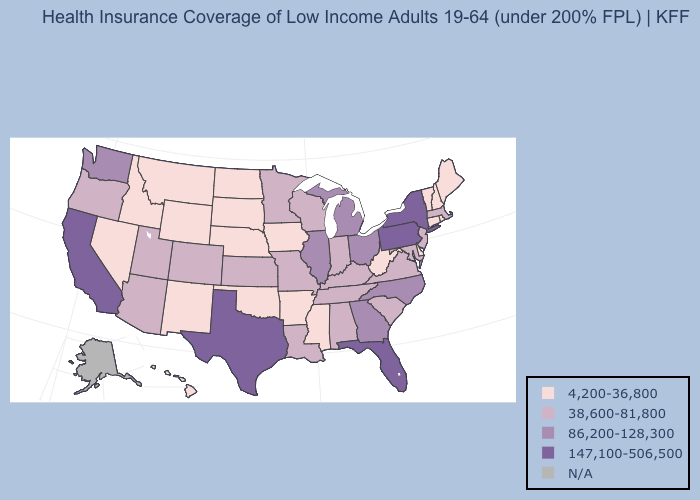Does Michigan have the highest value in the USA?
Answer briefly. No. Which states have the lowest value in the USA?
Be succinct. Arkansas, Connecticut, Delaware, Hawaii, Idaho, Iowa, Maine, Mississippi, Montana, Nebraska, Nevada, New Hampshire, New Mexico, North Dakota, Oklahoma, Rhode Island, South Dakota, Vermont, West Virginia, Wyoming. Name the states that have a value in the range 38,600-81,800?
Quick response, please. Alabama, Arizona, Colorado, Indiana, Kansas, Kentucky, Louisiana, Maryland, Massachusetts, Minnesota, Missouri, New Jersey, Oregon, South Carolina, Tennessee, Utah, Virginia, Wisconsin. Name the states that have a value in the range N/A?
Give a very brief answer. Alaska. What is the lowest value in the South?
Answer briefly. 4,200-36,800. What is the lowest value in states that border South Carolina?
Quick response, please. 86,200-128,300. Name the states that have a value in the range 147,100-506,500?
Give a very brief answer. California, Florida, New York, Pennsylvania, Texas. What is the highest value in the USA?
Quick response, please. 147,100-506,500. Name the states that have a value in the range 147,100-506,500?
Quick response, please. California, Florida, New York, Pennsylvania, Texas. Does the map have missing data?
Quick response, please. Yes. Does Kentucky have the highest value in the South?
Quick response, please. No. What is the highest value in the West ?
Write a very short answer. 147,100-506,500. What is the value of Texas?
Quick response, please. 147,100-506,500. What is the highest value in states that border Indiana?
Short answer required. 86,200-128,300. What is the highest value in states that border Minnesota?
Concise answer only. 38,600-81,800. 